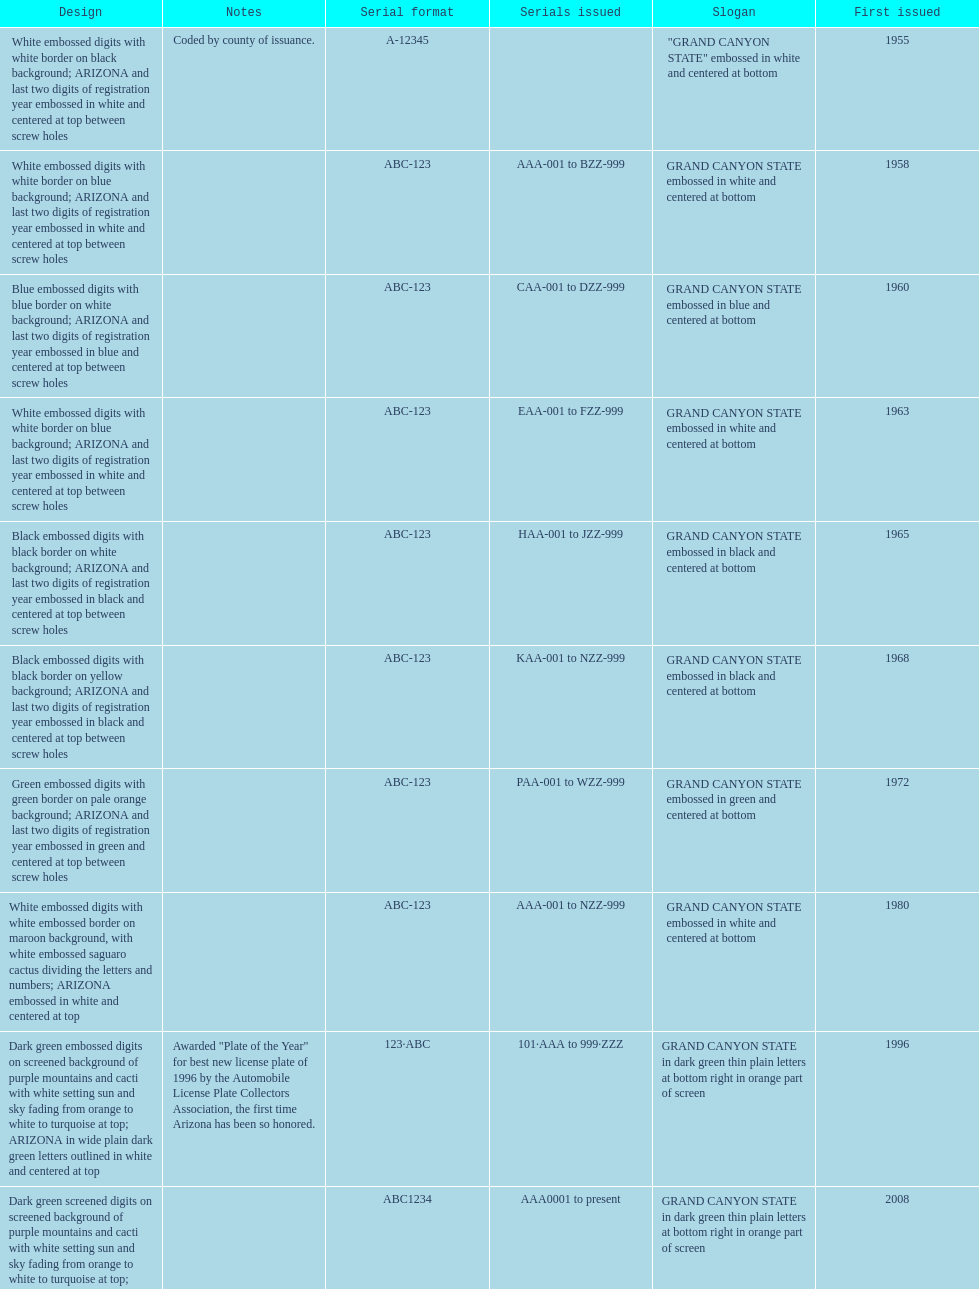Would you be able to parse every entry in this table? {'header': ['Design', 'Notes', 'Serial format', 'Serials issued', 'Slogan', 'First issued'], 'rows': [['White embossed digits with white border on black background; ARIZONA and last two digits of registration year embossed in white and centered at top between screw holes', 'Coded by county of issuance.', 'A-12345', '', '"GRAND CANYON STATE" embossed in white and centered at bottom', '1955'], ['White embossed digits with white border on blue background; ARIZONA and last two digits of registration year embossed in white and centered at top between screw holes', '', 'ABC-123', 'AAA-001 to BZZ-999', 'GRAND CANYON STATE embossed in white and centered at bottom', '1958'], ['Blue embossed digits with blue border on white background; ARIZONA and last two digits of registration year embossed in blue and centered at top between screw holes', '', 'ABC-123', 'CAA-001 to DZZ-999', 'GRAND CANYON STATE embossed in blue and centered at bottom', '1960'], ['White embossed digits with white border on blue background; ARIZONA and last two digits of registration year embossed in white and centered at top between screw holes', '', 'ABC-123', 'EAA-001 to FZZ-999', 'GRAND CANYON STATE embossed in white and centered at bottom', '1963'], ['Black embossed digits with black border on white background; ARIZONA and last two digits of registration year embossed in black and centered at top between screw holes', '', 'ABC-123', 'HAA-001 to JZZ-999', 'GRAND CANYON STATE embossed in black and centered at bottom', '1965'], ['Black embossed digits with black border on yellow background; ARIZONA and last two digits of registration year embossed in black and centered at top between screw holes', '', 'ABC-123', 'KAA-001 to NZZ-999', 'GRAND CANYON STATE embossed in black and centered at bottom', '1968'], ['Green embossed digits with green border on pale orange background; ARIZONA and last two digits of registration year embossed in green and centered at top between screw holes', '', 'ABC-123', 'PAA-001 to WZZ-999', 'GRAND CANYON STATE embossed in green and centered at bottom', '1972'], ['White embossed digits with white embossed border on maroon background, with white embossed saguaro cactus dividing the letters and numbers; ARIZONA embossed in white and centered at top', '', 'ABC-123', 'AAA-001 to NZZ-999', 'GRAND CANYON STATE embossed in white and centered at bottom', '1980'], ['Dark green embossed digits on screened background of purple mountains and cacti with white setting sun and sky fading from orange to white to turquoise at top; ARIZONA in wide plain dark green letters outlined in white and centered at top', 'Awarded "Plate of the Year" for best new license plate of 1996 by the Automobile License Plate Collectors Association, the first time Arizona has been so honored.', '123·ABC', '101·AAA to 999·ZZZ', 'GRAND CANYON STATE in dark green thin plain letters at bottom right in orange part of screen', '1996'], ['Dark green screened digits on screened background of purple mountains and cacti with white setting sun and sky fading from orange to white to turquoise at top; ARIZONA in wide plain dark green letters outlined in white and centered at top; security stripe through center of plate', '', 'ABC1234', 'AAA0001 to present', 'GRAND CANYON STATE in dark green thin plain letters at bottom right in orange part of screen', '2008']]} What was year was the first arizona license plate made? 1955. 